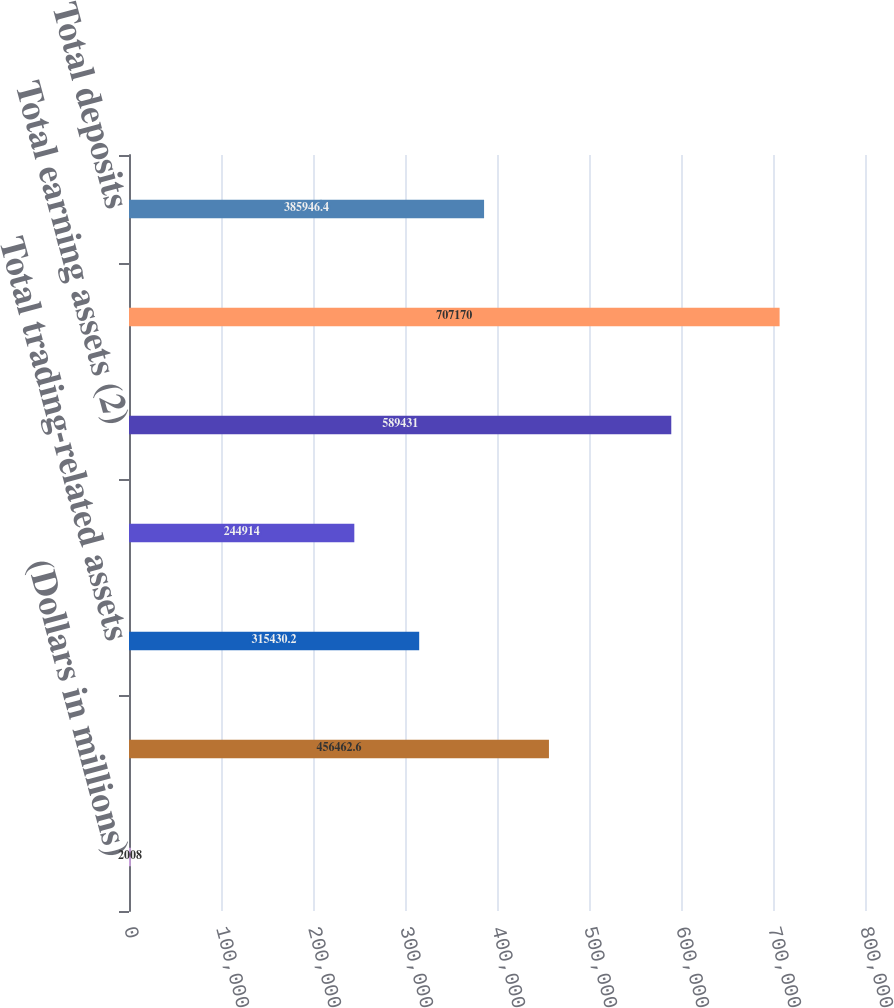Convert chart to OTSL. <chart><loc_0><loc_0><loc_500><loc_500><bar_chart><fcel>(Dollars in millions)<fcel>Total loans and leases<fcel>Total trading-related assets<fcel>Total market-based earning<fcel>Total earning assets (2)<fcel>Total assets (2)<fcel>Total deposits<nl><fcel>2008<fcel>456463<fcel>315430<fcel>244914<fcel>589431<fcel>707170<fcel>385946<nl></chart> 